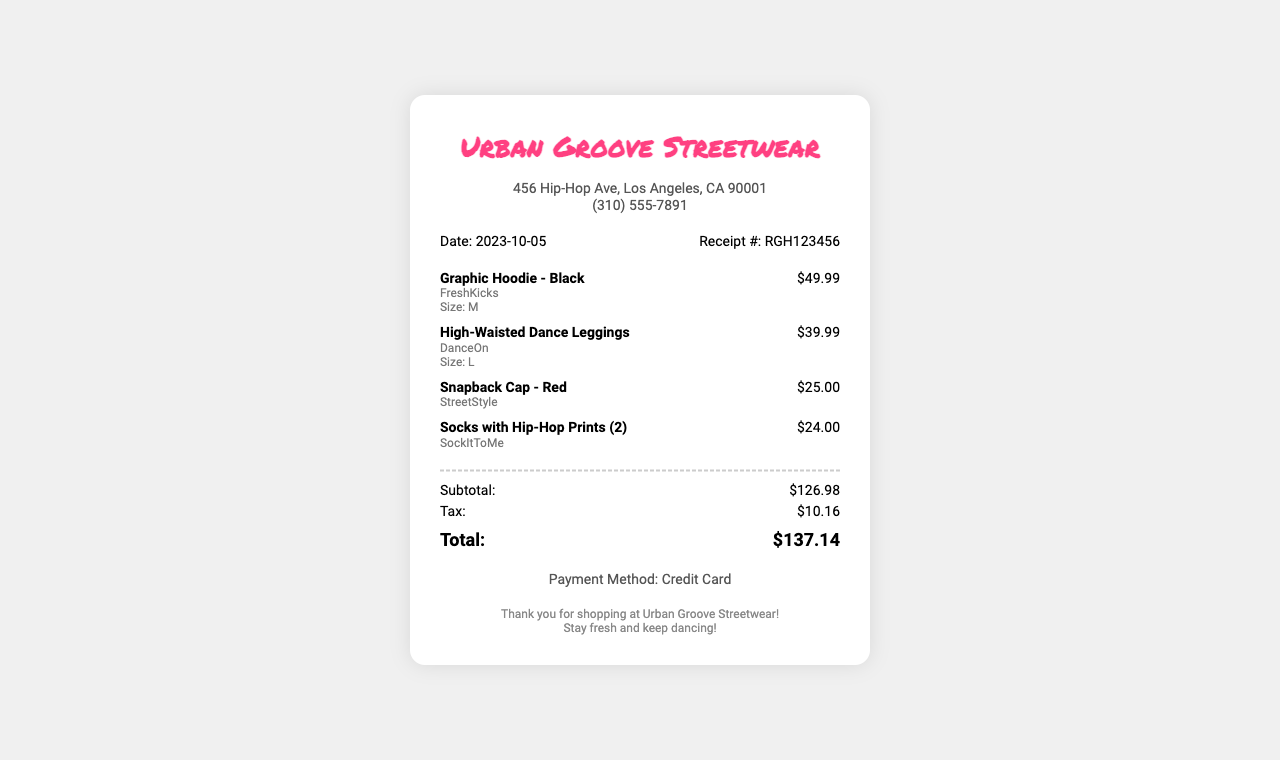What is the store name? The store name is prominently displayed at the top of the receipt.
Answer: Urban Groove Streetwear What is the date of the purchase? The date of the purchase is mentioned in the receipt details.
Answer: 2023-10-05 What is the total amount paid? The total amount is shown at the end of the totals section.
Answer: $137.14 What brand is the graphic hoodie? The brand of the hoodie is specified under the item details.
Answer: FreshKicks How many socks were purchased? The quantity of socks is indicated in the item description.
Answer: 2 What is the subtotal before tax? The subtotal is listed separately in the totals section before tax is added.
Answer: $126.98 What payment method was used? The payment method is mentioned at the bottom of the receipt.
Answer: Credit Card What size are the high-waisted dance leggings? The size of the leggings is shown in the item details.
Answer: L What color is the snapback cap? The color of the snapback cap is included in the item description.
Answer: Red 